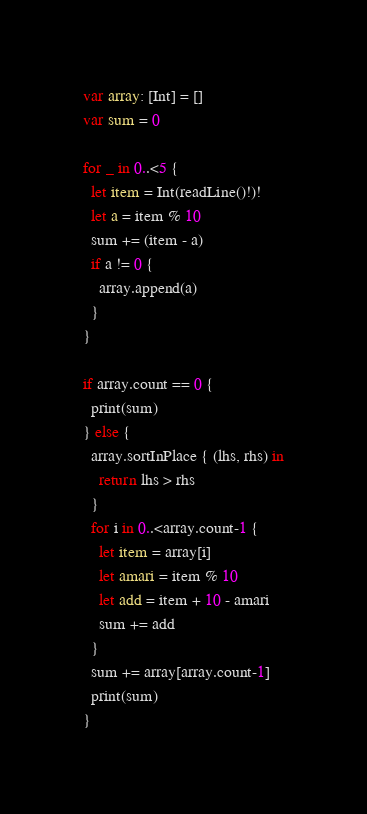Convert code to text. <code><loc_0><loc_0><loc_500><loc_500><_Swift_>var array: [Int] = []
var sum = 0

for _ in 0..<5 {
  let item = Int(readLine()!)!
  let a = item % 10
  sum += (item - a)
  if a != 0 {
    array.append(a)
  }
}

if array.count == 0 {
  print(sum)
} else {
  array.sortInPlace { (lhs, rhs) in
    return lhs > rhs
  }
  for i in 0..<array.count-1 {
    let item = array[i]
    let amari = item % 10
    let add = item + 10 - amari
    sum += add
  }
  sum += array[array.count-1]
  print(sum)
}
</code> 